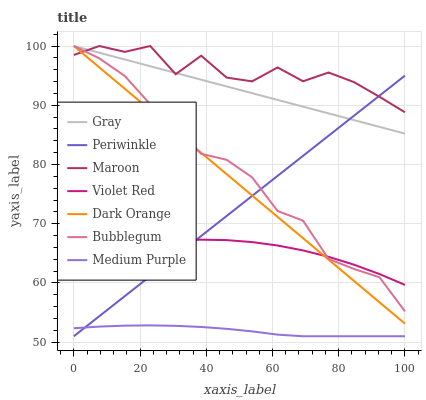Does Medium Purple have the minimum area under the curve?
Answer yes or no. Yes. Does Maroon have the maximum area under the curve?
Answer yes or no. Yes. Does Violet Red have the minimum area under the curve?
Answer yes or no. No. Does Violet Red have the maximum area under the curve?
Answer yes or no. No. Is Dark Orange the smoothest?
Answer yes or no. Yes. Is Maroon the roughest?
Answer yes or no. Yes. Is Violet Red the smoothest?
Answer yes or no. No. Is Violet Red the roughest?
Answer yes or no. No. Does Medium Purple have the lowest value?
Answer yes or no. Yes. Does Violet Red have the lowest value?
Answer yes or no. No. Does Maroon have the highest value?
Answer yes or no. Yes. Does Violet Red have the highest value?
Answer yes or no. No. Is Violet Red less than Maroon?
Answer yes or no. Yes. Is Gray greater than Medium Purple?
Answer yes or no. Yes. Does Bubblegum intersect Periwinkle?
Answer yes or no. Yes. Is Bubblegum less than Periwinkle?
Answer yes or no. No. Is Bubblegum greater than Periwinkle?
Answer yes or no. No. Does Violet Red intersect Maroon?
Answer yes or no. No. 